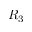<formula> <loc_0><loc_0><loc_500><loc_500>R _ { 3 }</formula> 